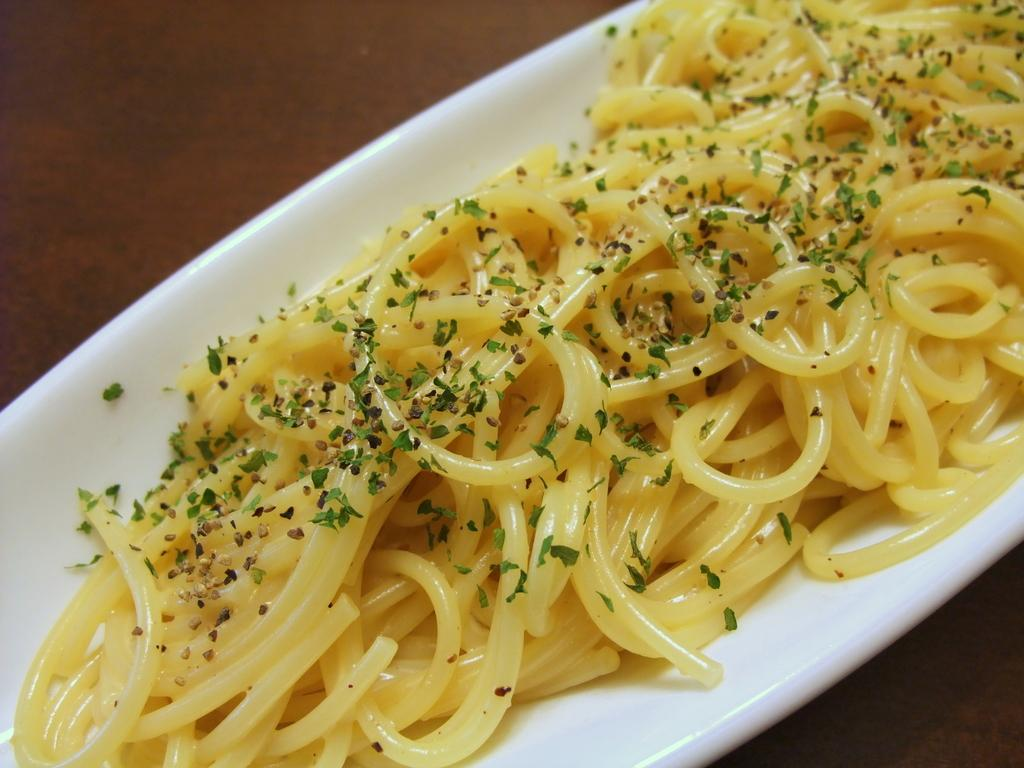What is on the plate that is visible in the image? The plate contains spaghetti. What is added to the spaghetti to enhance its flavor? The spaghetti has seasoning added to it. What is the color of the plate? The plate is white in color. Where is the plate located in the image? The plate is placed on a table. What type of leather material can be seen on the shirt in the image? There is no shirt or leather material present in the image; it features a plate of spaghetti on a table. 